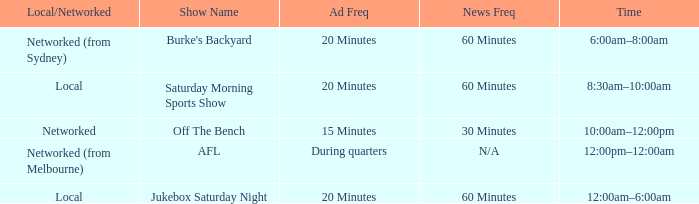What is the local/network with an Ad frequency of 15 minutes? Networked. 